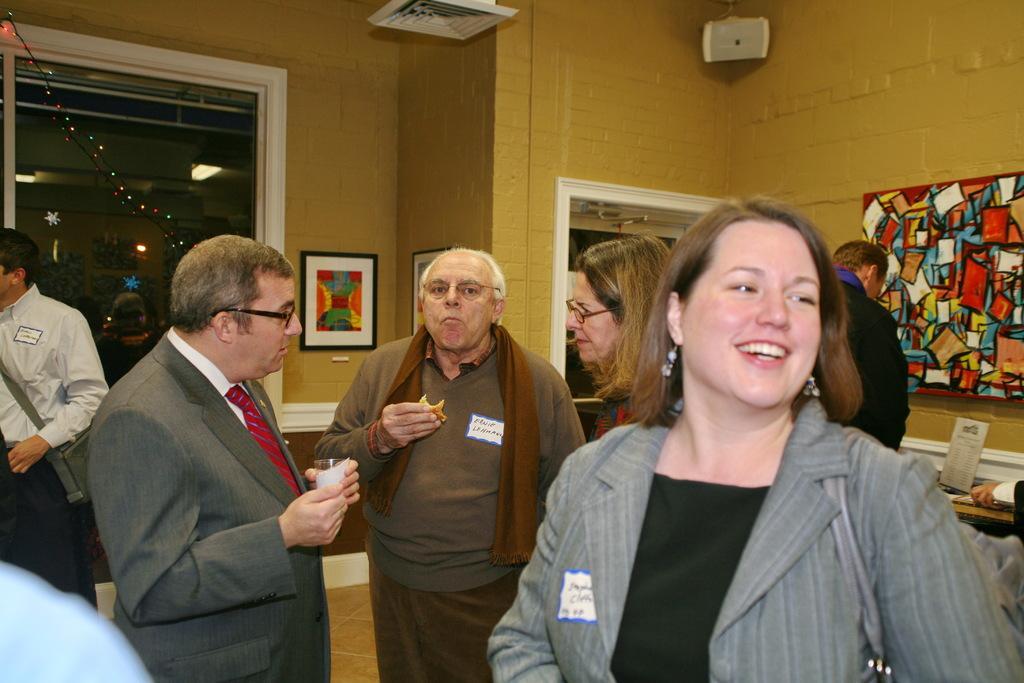In one or two sentences, can you explain what this image depicts? In this image we can see a few people, some of them are having cards on their dress with text on them, one person is eating a food item, another person is holding a glass, there are photo frames on the wall, we can see an object on the roof, there are serial lights, there is a window, also we can see a poster on the table. 